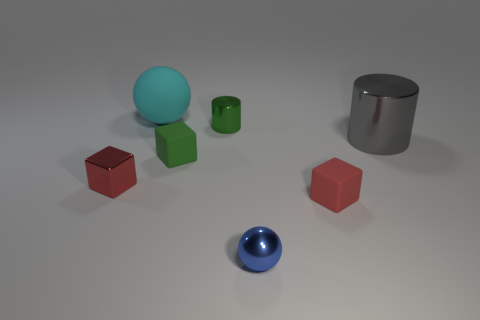Add 3 brown blocks. How many objects exist? 10 Subtract all blocks. How many objects are left? 4 Subtract all tiny green things. Subtract all small metallic spheres. How many objects are left? 4 Add 4 small red rubber blocks. How many small red rubber blocks are left? 5 Add 1 red metallic things. How many red metallic things exist? 2 Subtract 1 green cylinders. How many objects are left? 6 